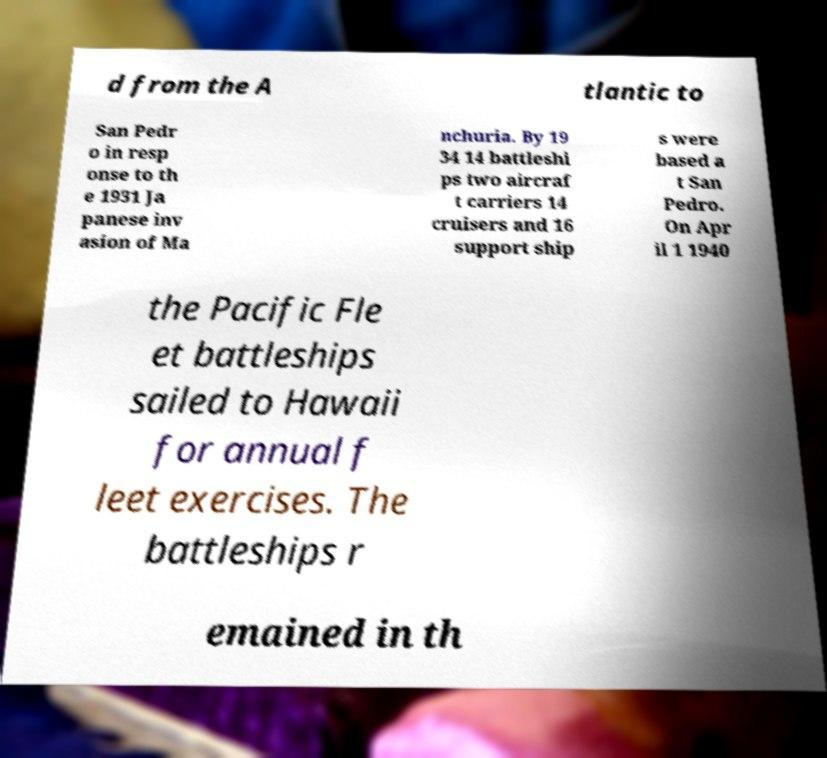Could you assist in decoding the text presented in this image and type it out clearly? d from the A tlantic to San Pedr o in resp onse to th e 1931 Ja panese inv asion of Ma nchuria. By 19 34 14 battleshi ps two aircraf t carriers 14 cruisers and 16 support ship s were based a t San Pedro. On Apr il 1 1940 the Pacific Fle et battleships sailed to Hawaii for annual f leet exercises. The battleships r emained in th 